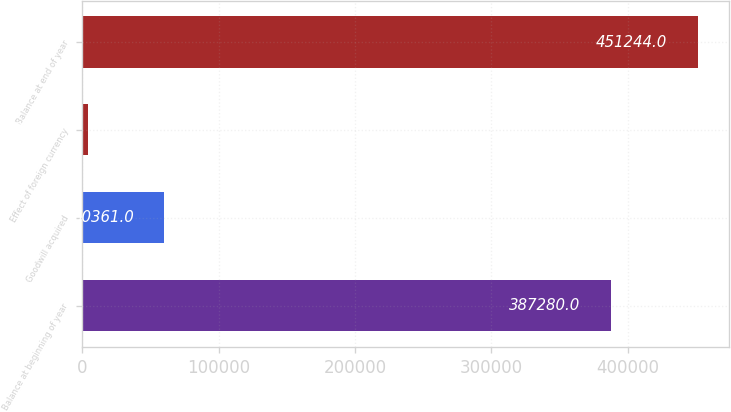<chart> <loc_0><loc_0><loc_500><loc_500><bar_chart><fcel>Balance at beginning of year<fcel>Goodwill acquired<fcel>Effect of foreign currency<fcel>Balance at end of year<nl><fcel>387280<fcel>60361<fcel>4301<fcel>451244<nl></chart> 